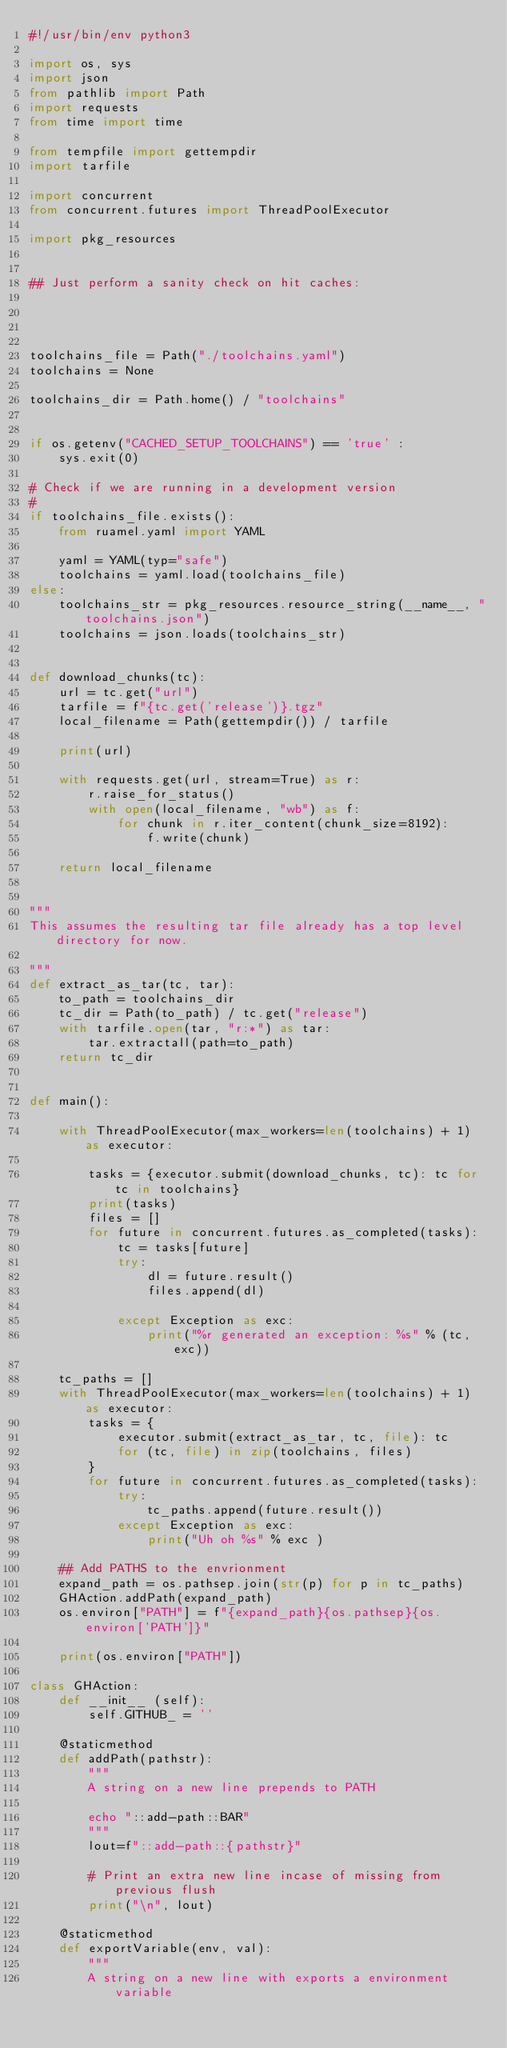Convert code to text. <code><loc_0><loc_0><loc_500><loc_500><_Python_>#!/usr/bin/env python3

import os, sys
import json
from pathlib import Path
import requests
from time import time

from tempfile import gettempdir
import tarfile

import concurrent
from concurrent.futures import ThreadPoolExecutor

import pkg_resources


## Just perform a sanity check on hit caches:




toolchains_file = Path("./toolchains.yaml")
toolchains = None

toolchains_dir = Path.home() / "toolchains"


if os.getenv("CACHED_SETUP_TOOLCHAINS") == 'true' :
    sys.exit(0)

# Check if we are running in a development version
#
if toolchains_file.exists():
    from ruamel.yaml import YAML

    yaml = YAML(typ="safe")
    toolchains = yaml.load(toolchains_file)
else:
    toolchains_str = pkg_resources.resource_string(__name__, "toolchains.json")
    toolchains = json.loads(toolchains_str)


def download_chunks(tc):
    url = tc.get("url")
    tarfile = f"{tc.get('release')}.tgz"
    local_filename = Path(gettempdir()) / tarfile

    print(url)

    with requests.get(url, stream=True) as r:
        r.raise_for_status()
        with open(local_filename, "wb") as f:
            for chunk in r.iter_content(chunk_size=8192):
                f.write(chunk)

    return local_filename


"""
This assumes the resulting tar file already has a top level directory for now.

"""
def extract_as_tar(tc, tar):
    to_path = toolchains_dir
    tc_dir = Path(to_path) / tc.get("release")
    with tarfile.open(tar, "r:*") as tar:
        tar.extractall(path=to_path)
    return tc_dir


def main():

    with ThreadPoolExecutor(max_workers=len(toolchains) + 1) as executor:

        tasks = {executor.submit(download_chunks, tc): tc for tc in toolchains}
        print(tasks)
        files = []
        for future in concurrent.futures.as_completed(tasks):
            tc = tasks[future]
            try:
                dl = future.result()
                files.append(dl)

            except Exception as exc:
                print("%r generated an exception: %s" % (tc, exc))

    tc_paths = []
    with ThreadPoolExecutor(max_workers=len(toolchains) + 1) as executor:
        tasks = {
            executor.submit(extract_as_tar, tc, file): tc
            for (tc, file) in zip(toolchains, files)
        }
        for future in concurrent.futures.as_completed(tasks):
            try:
                tc_paths.append(future.result())
            except Exception as exc:
                print("Uh oh %s" % exc )

    ## Add PATHS to the envrionment
    expand_path = os.pathsep.join(str(p) for p in tc_paths)
    GHAction.addPath(expand_path)
    os.environ["PATH"] = f"{expand_path}{os.pathsep}{os.environ['PATH']}"

    print(os.environ["PATH"])

class GHAction:
    def __init__ (self):
        self.GITHUB_ = ''

    @staticmethod
    def addPath(pathstr):
        """
        A string on a new line prepends to PATH

        echo "::add-path::BAR"
        """
        lout=f"::add-path::{pathstr}"
        
        # Print an extra new line incase of missing from previous flush
        print("\n", lout)

    @staticmethod
    def exportVariable(env, val):
        """
        A string on a new line with exports a environment variable
</code> 